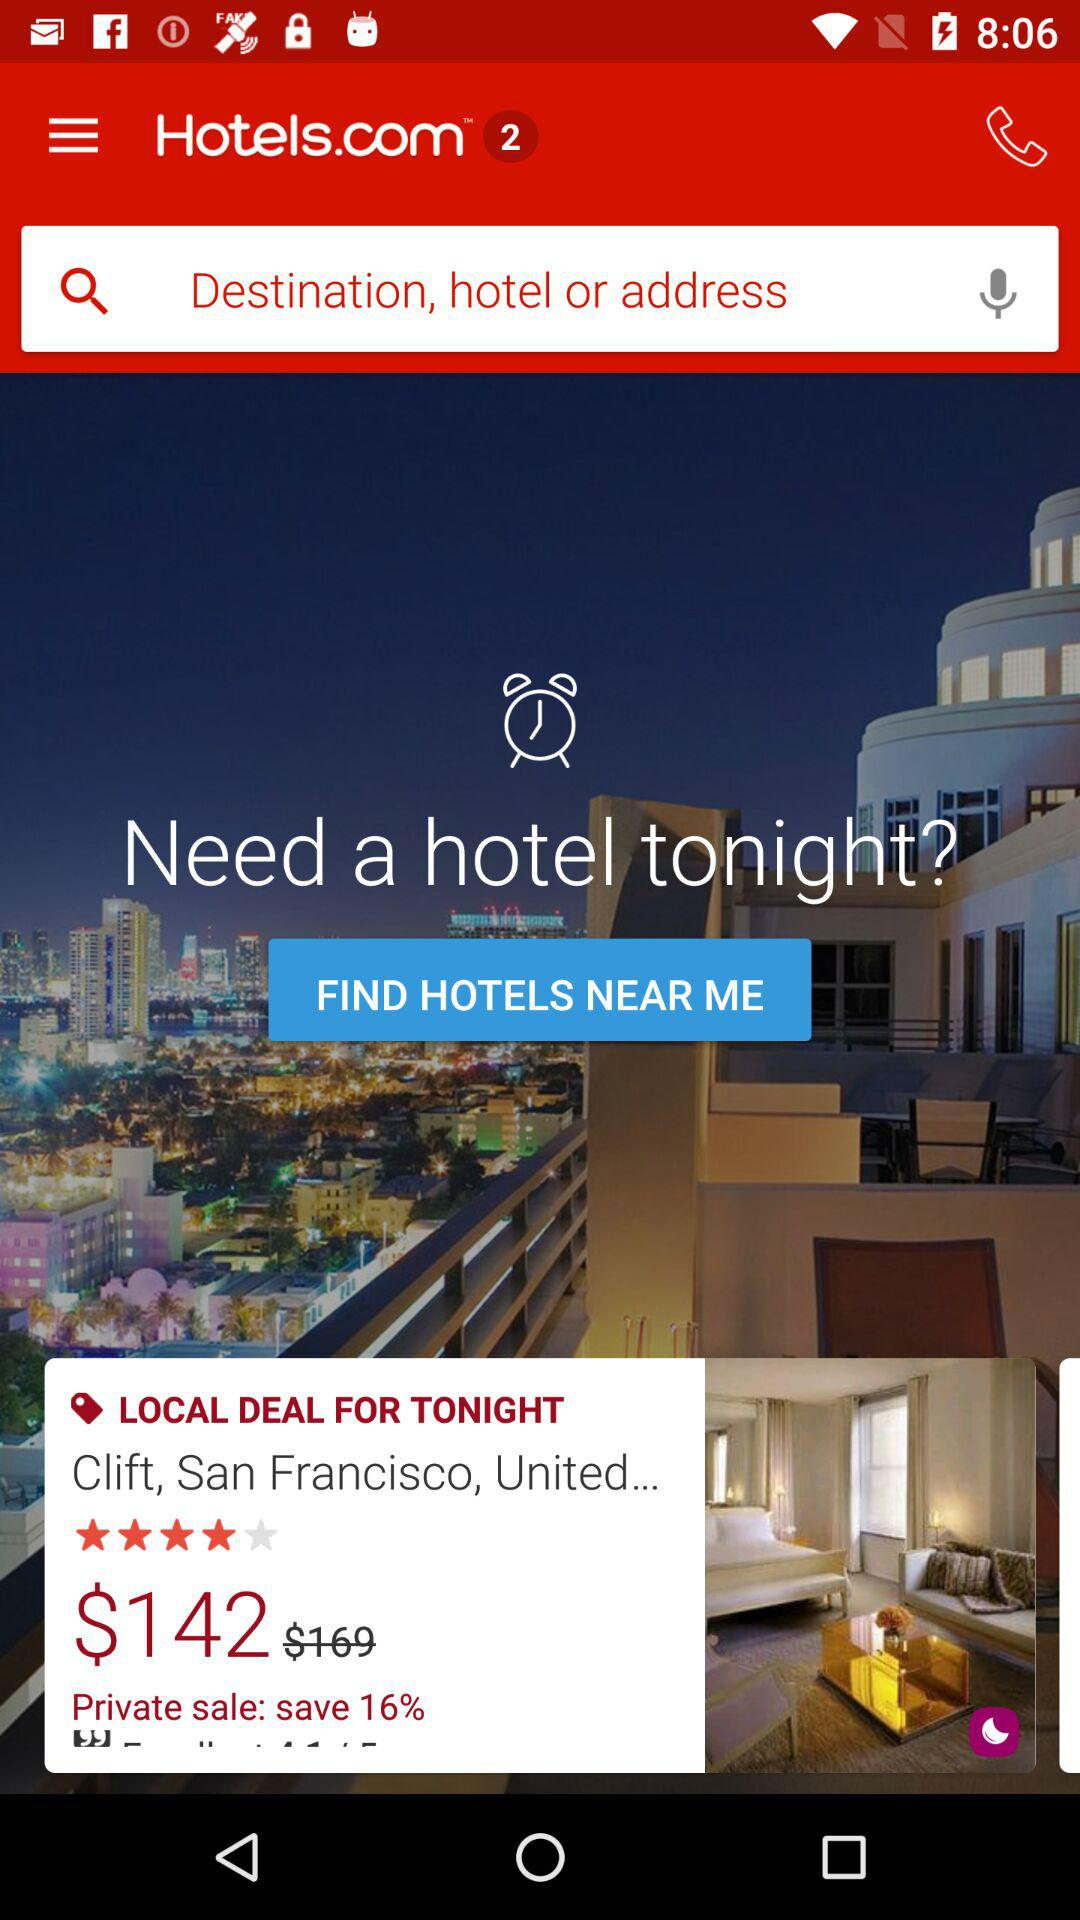What is the discounted price? The discounted price is $142. 